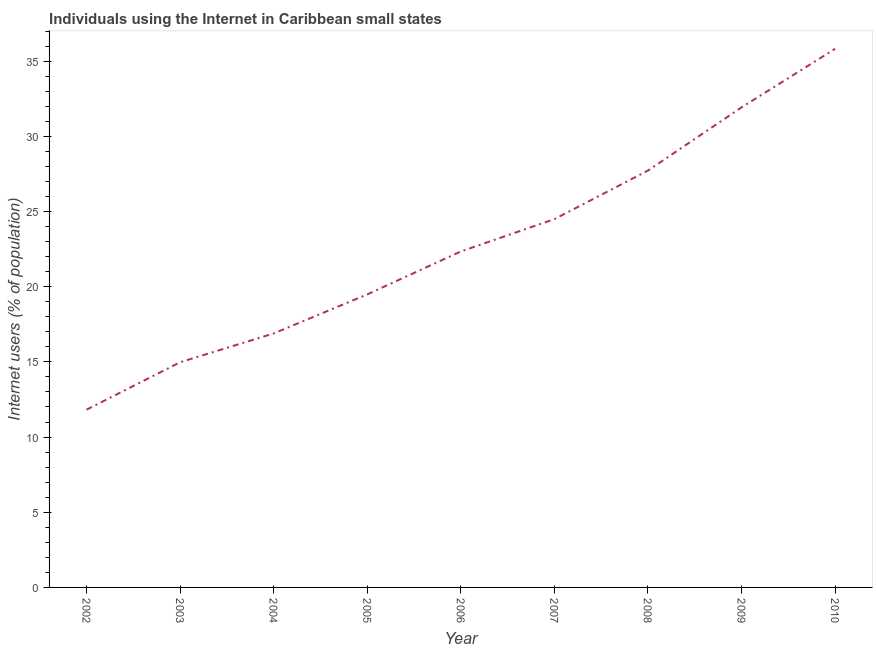What is the number of internet users in 2008?
Offer a terse response. 27.72. Across all years, what is the maximum number of internet users?
Your answer should be compact. 35.82. Across all years, what is the minimum number of internet users?
Make the answer very short. 11.82. What is the sum of the number of internet users?
Ensure brevity in your answer.  205.49. What is the difference between the number of internet users in 2005 and 2010?
Offer a terse response. -16.33. What is the average number of internet users per year?
Provide a succinct answer. 22.83. What is the median number of internet users?
Offer a very short reply. 22.34. In how many years, is the number of internet users greater than 10 %?
Give a very brief answer. 9. What is the ratio of the number of internet users in 2008 to that in 2009?
Offer a terse response. 0.87. Is the difference between the number of internet users in 2003 and 2007 greater than the difference between any two years?
Offer a terse response. No. What is the difference between the highest and the second highest number of internet users?
Provide a short and direct response. 3.89. Is the sum of the number of internet users in 2005 and 2010 greater than the maximum number of internet users across all years?
Provide a short and direct response. Yes. What is the difference between the highest and the lowest number of internet users?
Make the answer very short. 24. How many years are there in the graph?
Ensure brevity in your answer.  9. What is the difference between two consecutive major ticks on the Y-axis?
Offer a very short reply. 5. Does the graph contain any zero values?
Your response must be concise. No. Does the graph contain grids?
Give a very brief answer. No. What is the title of the graph?
Keep it short and to the point. Individuals using the Internet in Caribbean small states. What is the label or title of the Y-axis?
Ensure brevity in your answer.  Internet users (% of population). What is the Internet users (% of population) of 2002?
Provide a succinct answer. 11.82. What is the Internet users (% of population) in 2003?
Keep it short and to the point. 14.98. What is the Internet users (% of population) in 2004?
Make the answer very short. 16.89. What is the Internet users (% of population) in 2005?
Offer a terse response. 19.49. What is the Internet users (% of population) of 2006?
Offer a terse response. 22.34. What is the Internet users (% of population) of 2007?
Your answer should be very brief. 24.49. What is the Internet users (% of population) of 2008?
Your answer should be very brief. 27.72. What is the Internet users (% of population) of 2009?
Offer a terse response. 31.93. What is the Internet users (% of population) of 2010?
Your answer should be compact. 35.82. What is the difference between the Internet users (% of population) in 2002 and 2003?
Provide a succinct answer. -3.15. What is the difference between the Internet users (% of population) in 2002 and 2004?
Give a very brief answer. -5.07. What is the difference between the Internet users (% of population) in 2002 and 2005?
Your answer should be very brief. -7.67. What is the difference between the Internet users (% of population) in 2002 and 2006?
Your answer should be compact. -10.52. What is the difference between the Internet users (% of population) in 2002 and 2007?
Make the answer very short. -12.67. What is the difference between the Internet users (% of population) in 2002 and 2008?
Your response must be concise. -15.9. What is the difference between the Internet users (% of population) in 2002 and 2009?
Provide a short and direct response. -20.1. What is the difference between the Internet users (% of population) in 2002 and 2010?
Keep it short and to the point. -24. What is the difference between the Internet users (% of population) in 2003 and 2004?
Your answer should be very brief. -1.92. What is the difference between the Internet users (% of population) in 2003 and 2005?
Your answer should be very brief. -4.51. What is the difference between the Internet users (% of population) in 2003 and 2006?
Your answer should be compact. -7.37. What is the difference between the Internet users (% of population) in 2003 and 2007?
Make the answer very short. -9.52. What is the difference between the Internet users (% of population) in 2003 and 2008?
Keep it short and to the point. -12.75. What is the difference between the Internet users (% of population) in 2003 and 2009?
Offer a very short reply. -16.95. What is the difference between the Internet users (% of population) in 2003 and 2010?
Offer a terse response. -20.84. What is the difference between the Internet users (% of population) in 2004 and 2005?
Provide a short and direct response. -2.6. What is the difference between the Internet users (% of population) in 2004 and 2006?
Offer a very short reply. -5.45. What is the difference between the Internet users (% of population) in 2004 and 2007?
Your answer should be compact. -7.6. What is the difference between the Internet users (% of population) in 2004 and 2008?
Your response must be concise. -10.83. What is the difference between the Internet users (% of population) in 2004 and 2009?
Provide a short and direct response. -15.04. What is the difference between the Internet users (% of population) in 2004 and 2010?
Offer a very short reply. -18.93. What is the difference between the Internet users (% of population) in 2005 and 2006?
Your answer should be compact. -2.86. What is the difference between the Internet users (% of population) in 2005 and 2007?
Provide a succinct answer. -5. What is the difference between the Internet users (% of population) in 2005 and 2008?
Keep it short and to the point. -8.24. What is the difference between the Internet users (% of population) in 2005 and 2009?
Ensure brevity in your answer.  -12.44. What is the difference between the Internet users (% of population) in 2005 and 2010?
Provide a succinct answer. -16.33. What is the difference between the Internet users (% of population) in 2006 and 2007?
Provide a short and direct response. -2.15. What is the difference between the Internet users (% of population) in 2006 and 2008?
Ensure brevity in your answer.  -5.38. What is the difference between the Internet users (% of population) in 2006 and 2009?
Give a very brief answer. -9.58. What is the difference between the Internet users (% of population) in 2006 and 2010?
Make the answer very short. -13.47. What is the difference between the Internet users (% of population) in 2007 and 2008?
Your answer should be very brief. -3.23. What is the difference between the Internet users (% of population) in 2007 and 2009?
Provide a short and direct response. -7.43. What is the difference between the Internet users (% of population) in 2007 and 2010?
Your answer should be compact. -11.32. What is the difference between the Internet users (% of population) in 2008 and 2009?
Your response must be concise. -4.2. What is the difference between the Internet users (% of population) in 2008 and 2010?
Provide a succinct answer. -8.09. What is the difference between the Internet users (% of population) in 2009 and 2010?
Keep it short and to the point. -3.89. What is the ratio of the Internet users (% of population) in 2002 to that in 2003?
Provide a succinct answer. 0.79. What is the ratio of the Internet users (% of population) in 2002 to that in 2004?
Your answer should be compact. 0.7. What is the ratio of the Internet users (% of population) in 2002 to that in 2005?
Your response must be concise. 0.61. What is the ratio of the Internet users (% of population) in 2002 to that in 2006?
Provide a short and direct response. 0.53. What is the ratio of the Internet users (% of population) in 2002 to that in 2007?
Keep it short and to the point. 0.48. What is the ratio of the Internet users (% of population) in 2002 to that in 2008?
Provide a succinct answer. 0.43. What is the ratio of the Internet users (% of population) in 2002 to that in 2009?
Make the answer very short. 0.37. What is the ratio of the Internet users (% of population) in 2002 to that in 2010?
Provide a short and direct response. 0.33. What is the ratio of the Internet users (% of population) in 2003 to that in 2004?
Provide a succinct answer. 0.89. What is the ratio of the Internet users (% of population) in 2003 to that in 2005?
Your answer should be very brief. 0.77. What is the ratio of the Internet users (% of population) in 2003 to that in 2006?
Provide a short and direct response. 0.67. What is the ratio of the Internet users (% of population) in 2003 to that in 2007?
Your answer should be very brief. 0.61. What is the ratio of the Internet users (% of population) in 2003 to that in 2008?
Offer a very short reply. 0.54. What is the ratio of the Internet users (% of population) in 2003 to that in 2009?
Your answer should be very brief. 0.47. What is the ratio of the Internet users (% of population) in 2003 to that in 2010?
Make the answer very short. 0.42. What is the ratio of the Internet users (% of population) in 2004 to that in 2005?
Make the answer very short. 0.87. What is the ratio of the Internet users (% of population) in 2004 to that in 2006?
Give a very brief answer. 0.76. What is the ratio of the Internet users (% of population) in 2004 to that in 2007?
Offer a terse response. 0.69. What is the ratio of the Internet users (% of population) in 2004 to that in 2008?
Provide a short and direct response. 0.61. What is the ratio of the Internet users (% of population) in 2004 to that in 2009?
Provide a succinct answer. 0.53. What is the ratio of the Internet users (% of population) in 2004 to that in 2010?
Provide a short and direct response. 0.47. What is the ratio of the Internet users (% of population) in 2005 to that in 2006?
Offer a very short reply. 0.87. What is the ratio of the Internet users (% of population) in 2005 to that in 2007?
Your answer should be compact. 0.8. What is the ratio of the Internet users (% of population) in 2005 to that in 2008?
Ensure brevity in your answer.  0.7. What is the ratio of the Internet users (% of population) in 2005 to that in 2009?
Your response must be concise. 0.61. What is the ratio of the Internet users (% of population) in 2005 to that in 2010?
Your answer should be very brief. 0.54. What is the ratio of the Internet users (% of population) in 2006 to that in 2007?
Your answer should be very brief. 0.91. What is the ratio of the Internet users (% of population) in 2006 to that in 2008?
Keep it short and to the point. 0.81. What is the ratio of the Internet users (% of population) in 2006 to that in 2010?
Provide a succinct answer. 0.62. What is the ratio of the Internet users (% of population) in 2007 to that in 2008?
Offer a very short reply. 0.88. What is the ratio of the Internet users (% of population) in 2007 to that in 2009?
Provide a succinct answer. 0.77. What is the ratio of the Internet users (% of population) in 2007 to that in 2010?
Offer a very short reply. 0.68. What is the ratio of the Internet users (% of population) in 2008 to that in 2009?
Provide a succinct answer. 0.87. What is the ratio of the Internet users (% of population) in 2008 to that in 2010?
Your answer should be compact. 0.77. What is the ratio of the Internet users (% of population) in 2009 to that in 2010?
Give a very brief answer. 0.89. 